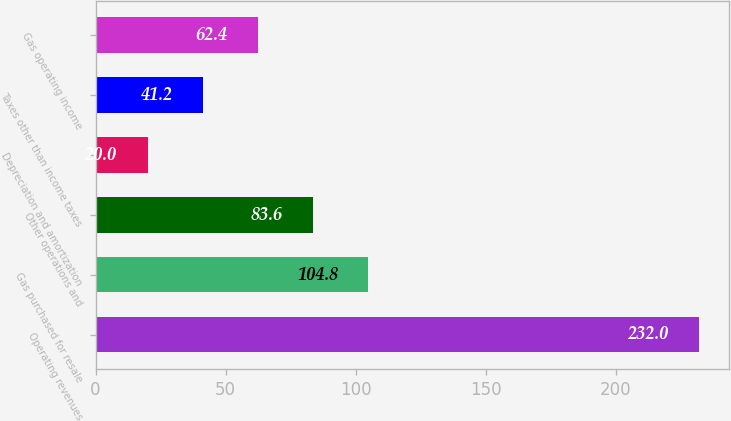Convert chart. <chart><loc_0><loc_0><loc_500><loc_500><bar_chart><fcel>Operating revenues<fcel>Gas purchased for resale<fcel>Other operations and<fcel>Depreciation and amortization<fcel>Taxes other than income taxes<fcel>Gas operating income<nl><fcel>232<fcel>104.8<fcel>83.6<fcel>20<fcel>41.2<fcel>62.4<nl></chart> 